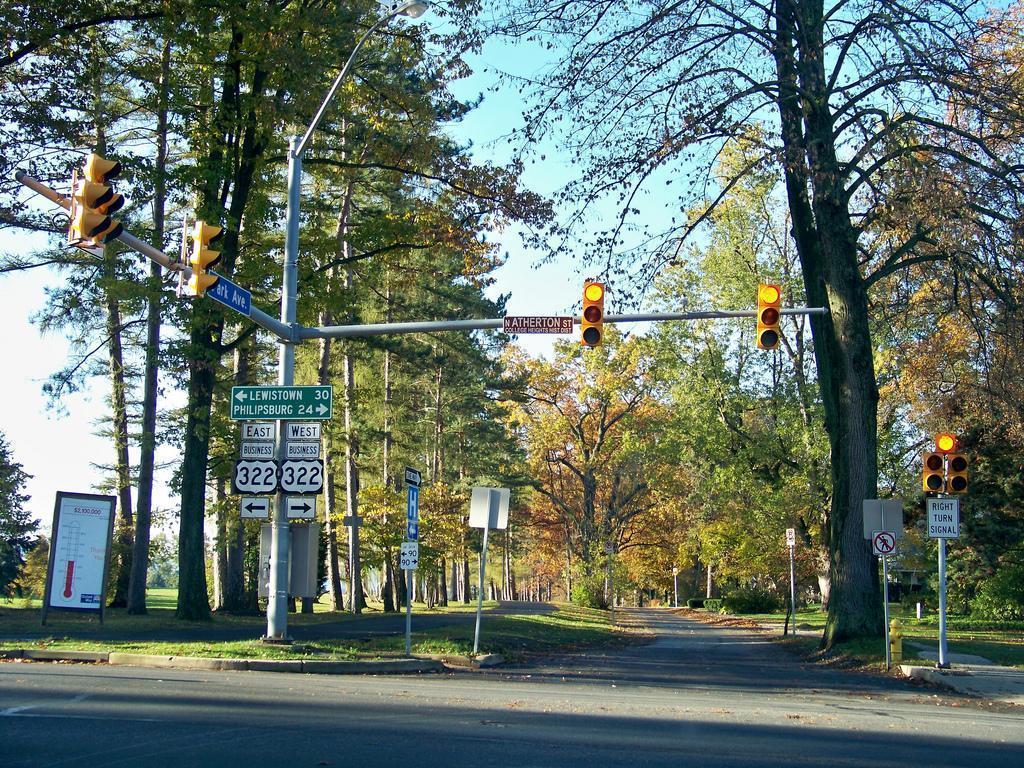How many lit up lights are there?
Give a very brief answer. 3. How many directional street signs are there?
Give a very brief answer. 9. How many East signs?
Give a very brief answer. 1. How many signs say 322?
Give a very brief answer. 2. How many signal lights are there?
Give a very brief answer. 5. 